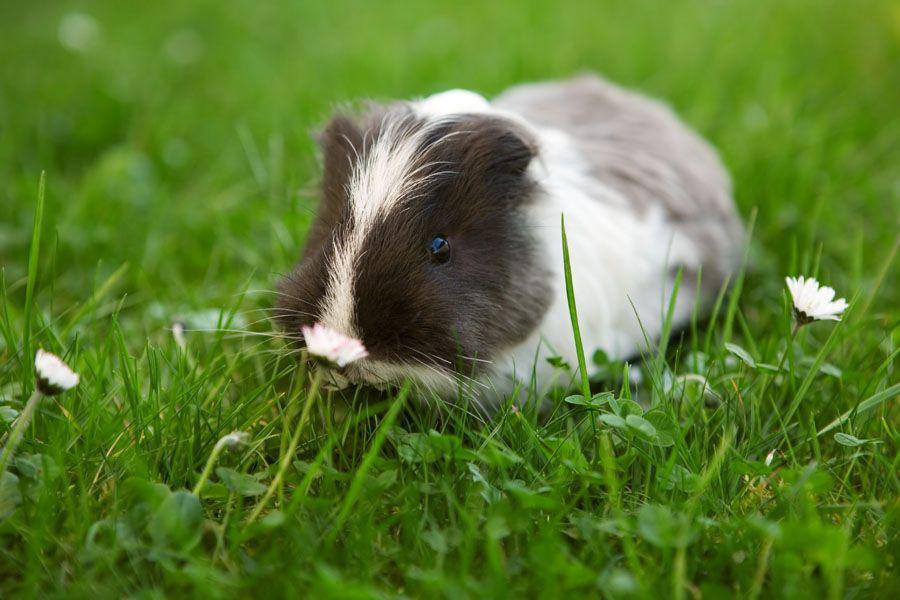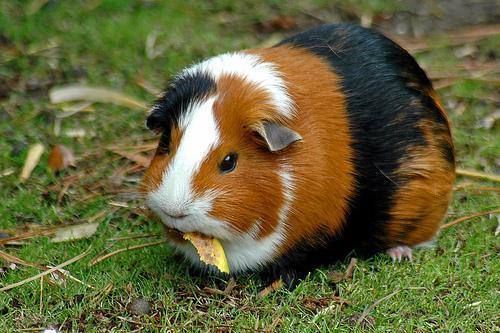The first image is the image on the left, the second image is the image on the right. Assess this claim about the two images: "The left image shows a guinea pig standing on grass near tiny white flowers, and the right image shows one guinea pig with something yellowish in its mouth.". Correct or not? Answer yes or no. Yes. The first image is the image on the left, the second image is the image on the right. For the images shown, is this caption "One of the images features a guinea pig munching on foliage." true? Answer yes or no. Yes. 